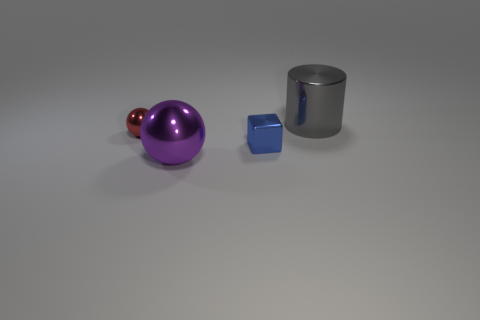Add 3 small blue shiny things. How many objects exist? 7 Subtract all blocks. How many objects are left? 3 Add 4 gray things. How many gray things are left? 5 Add 3 cylinders. How many cylinders exist? 4 Subtract 0 gray spheres. How many objects are left? 4 Subtract all brown matte things. Subtract all tiny red spheres. How many objects are left? 3 